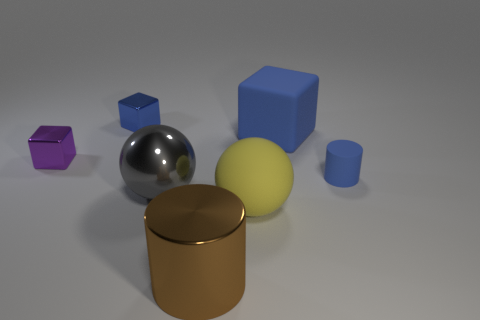What is the size of the metal thing that is the same color as the large cube?
Your answer should be very brief. Small. There is a rubber thing that is the same shape as the purple shiny object; what is its size?
Provide a short and direct response. Large. What material is the blue thing behind the large rubber object that is behind the blue cylinder?
Your answer should be compact. Metal. How many rubber things are blue cylinders or big blocks?
Ensure brevity in your answer.  2. There is a tiny thing that is the same shape as the big brown shiny object; what color is it?
Provide a succinct answer. Blue. What number of shiny blocks have the same color as the small cylinder?
Your answer should be compact. 1. Is there a metallic block that is right of the big metal object that is in front of the gray thing?
Your response must be concise. No. What number of large shiny things are in front of the gray ball and behind the big brown shiny cylinder?
Make the answer very short. 0. What number of big cubes are made of the same material as the brown cylinder?
Make the answer very short. 0. There is a blue rubber object in front of the blue cube that is to the right of the large metallic cylinder; what is its size?
Offer a terse response. Small. 